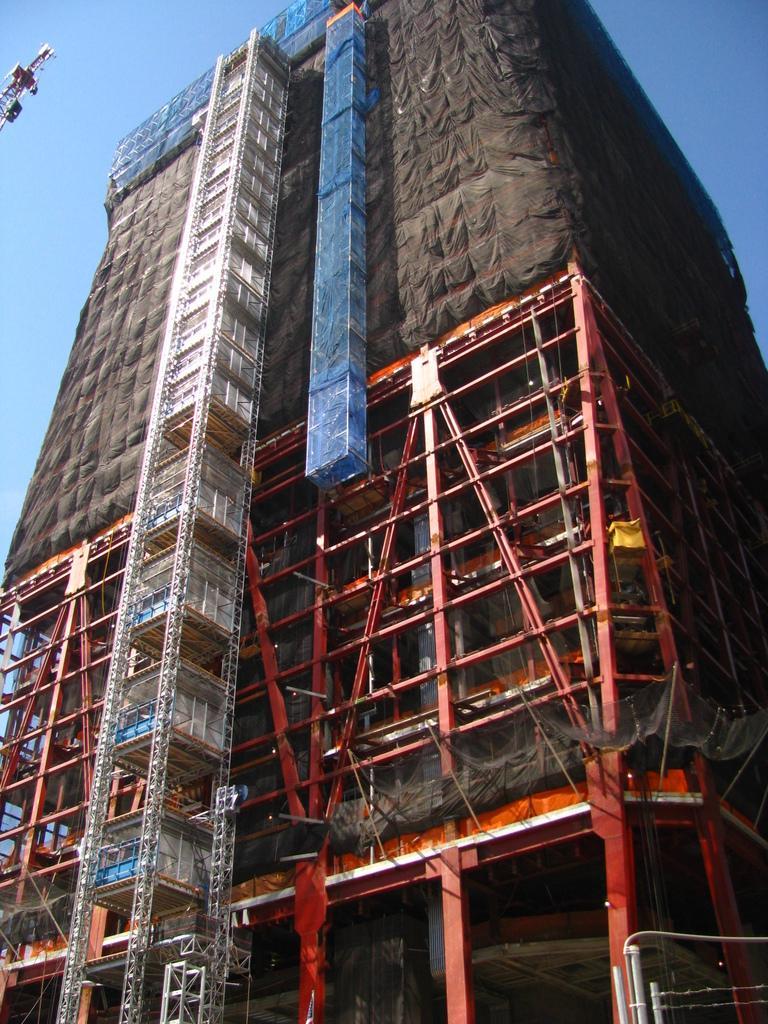Could you give a brief overview of what you see in this image? In this image in the center there is a building, and there are some iron poles. At the top there is sky. 